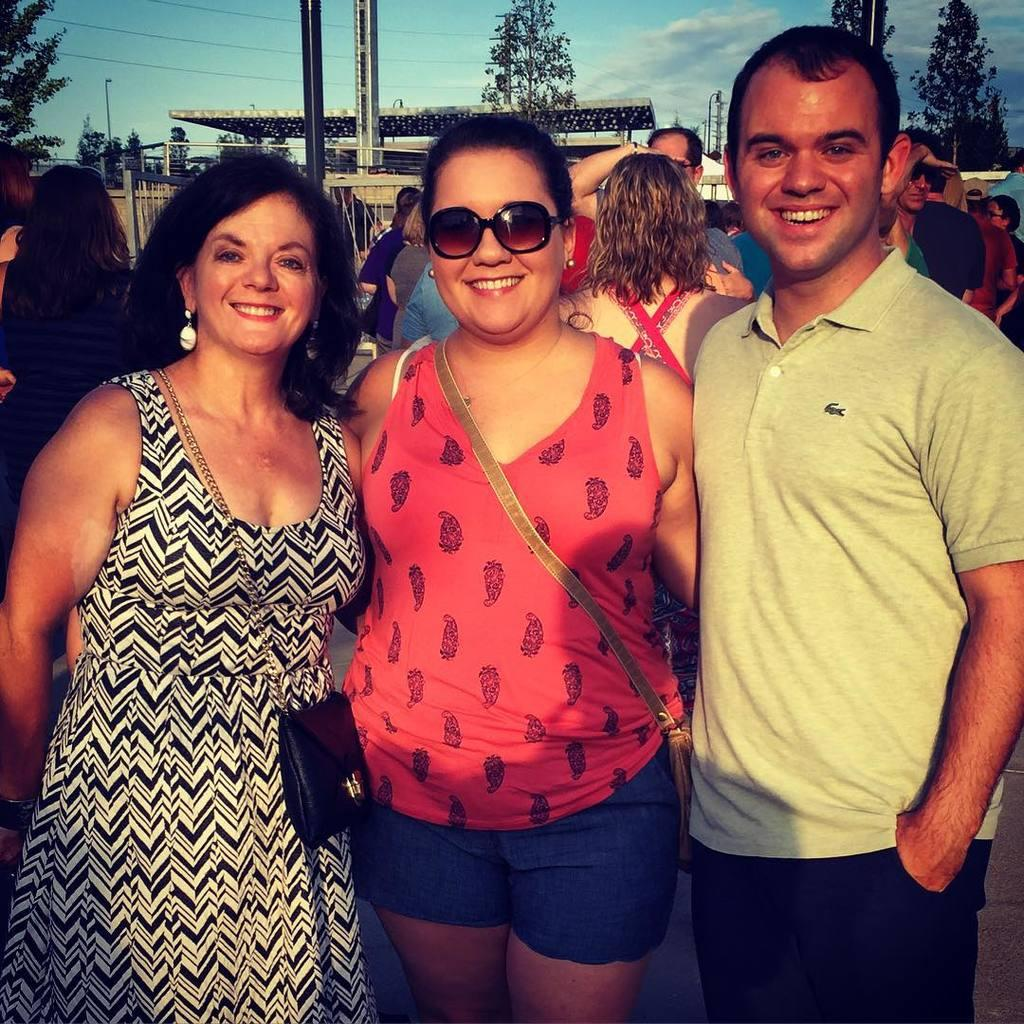How many women are in the image? There are two women in the image. What are the women doing in the image? The women are posing for a photograph. Can you describe the background of the image? There are people and trees in the background of the image, and the sky is visible. What type of invention can be seen in the stomach of one of the women in the image? There is no invention or any reference to a stomach in the image; it features two women posing for a photograph. 